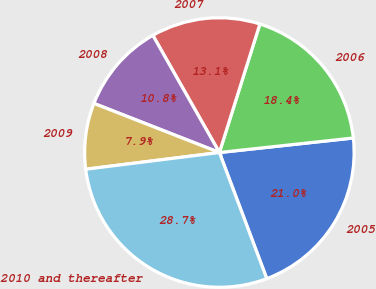Convert chart. <chart><loc_0><loc_0><loc_500><loc_500><pie_chart><fcel>2005<fcel>2006<fcel>2007<fcel>2008<fcel>2009<fcel>2010 and thereafter<nl><fcel>21.0%<fcel>18.42%<fcel>13.08%<fcel>10.84%<fcel>7.92%<fcel>28.74%<nl></chart> 